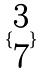<formula> <loc_0><loc_0><loc_500><loc_500>\{ \begin{matrix} 3 \\ 7 \end{matrix} \}</formula> 